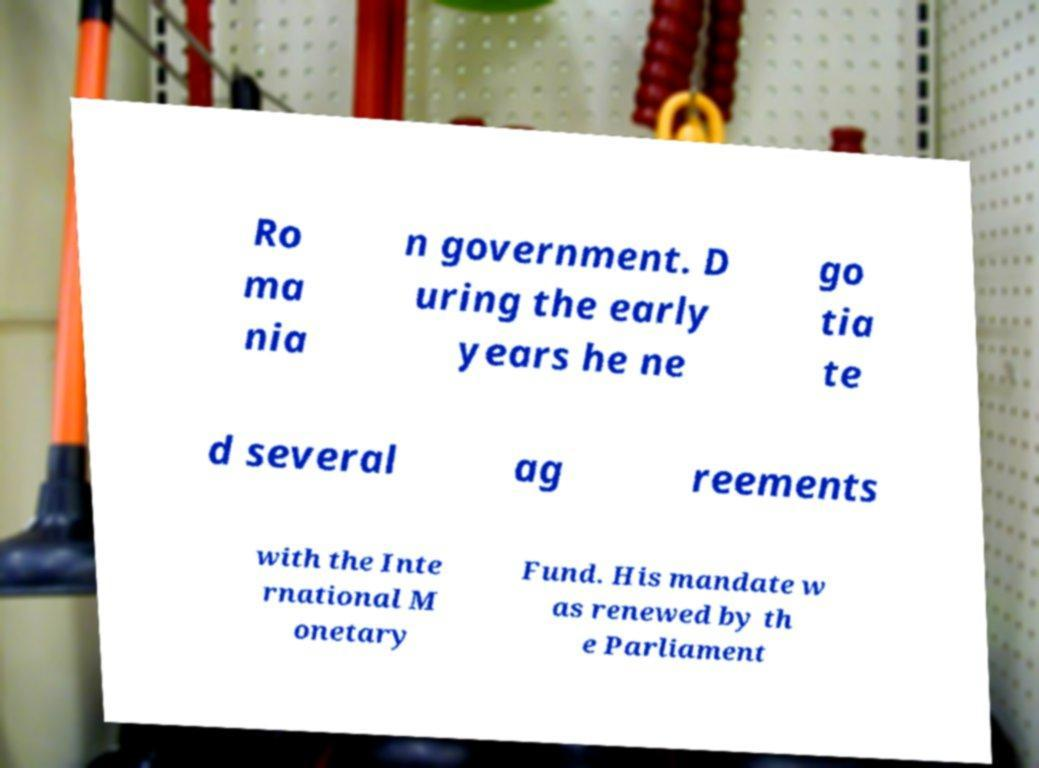I need the written content from this picture converted into text. Can you do that? Ro ma nia n government. D uring the early years he ne go tia te d several ag reements with the Inte rnational M onetary Fund. His mandate w as renewed by th e Parliament 